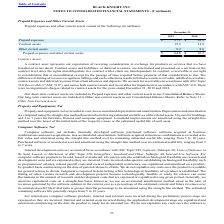According to Black Knight Financial Services's financial document, What does a contract asset represent to the company? our expectation of receiving consideration in exchange for products or services that we have transferred to our client.. The document states: "A contract asset represents our expectation of receiving consideration in exchange for products or services that we have transferred to our client. Co..." Also, What were the prepaid expenses in 2018? According to the financial document, 43.9 (in millions). The relevant text states: "Prepaid expenses $ 37.1 $ 43.9..." Also, What were the Other current assets in 2019? According to the financial document, 8.2 (in millions). The relevant text states: "Other current assets 8.2 8.6..." Also, can you calculate: What was the change in contract assets between 2018 and 2019? Based on the calculation: 19.5-14.8, the result is 4.7 (in millions). This is based on the information: "Contract assets 19.5 14.8 Contract assets 19.5 14.8..." The key data points involved are: 14.8, 19.5. Also, How many years did prepaid expenses exceed $40.0 million? Based on the analysis, there are 1 instances (in millions). The counting process: 2018. Also, can you calculate: What was the percentage change in Other current assets between 2018 and 2019? To answer this question, I need to perform calculations using the financial data. The calculation is: (8.2-8.6)/8.6, which equals -4.65 (percentage). This is based on the information: "Other current assets 8.2 8.6 Other current assets 8.2 8.6..." The key data points involved are: 8.2, 8.6. 